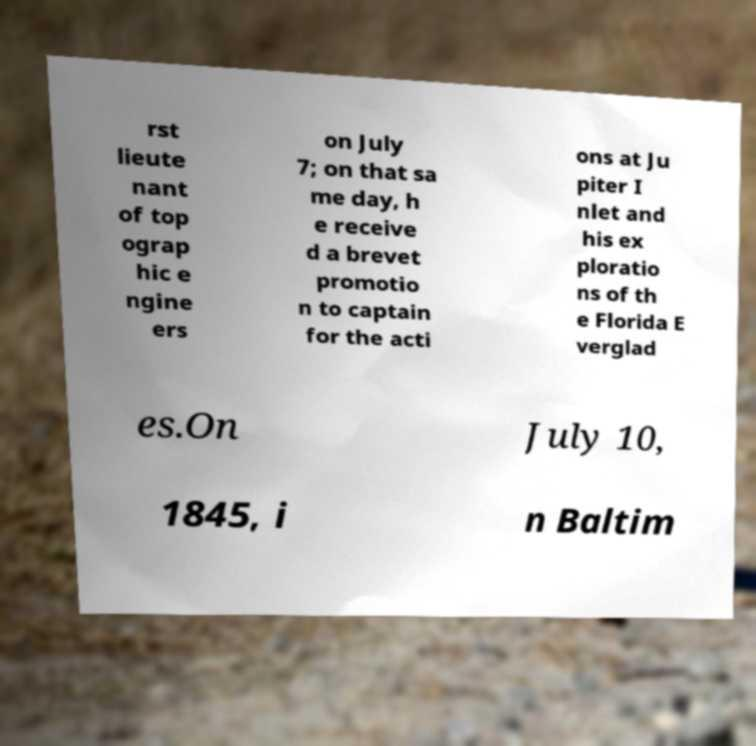Please read and relay the text visible in this image. What does it say? rst lieute nant of top ograp hic e ngine ers on July 7; on that sa me day, h e receive d a brevet promotio n to captain for the acti ons at Ju piter I nlet and his ex ploratio ns of th e Florida E verglad es.On July 10, 1845, i n Baltim 